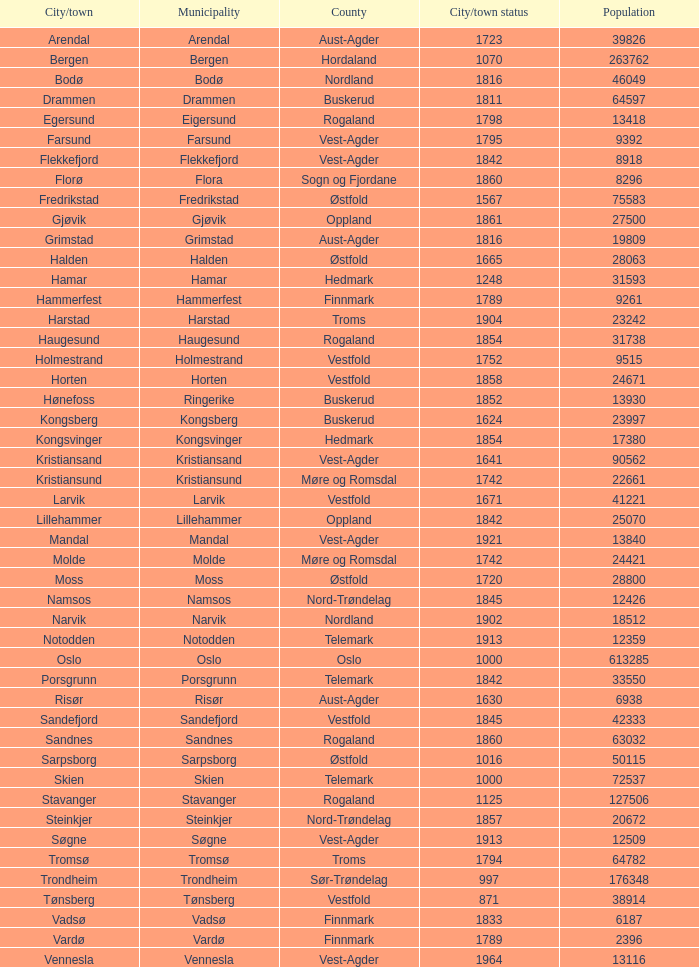Which municipality has a population of 24421? Molde. 